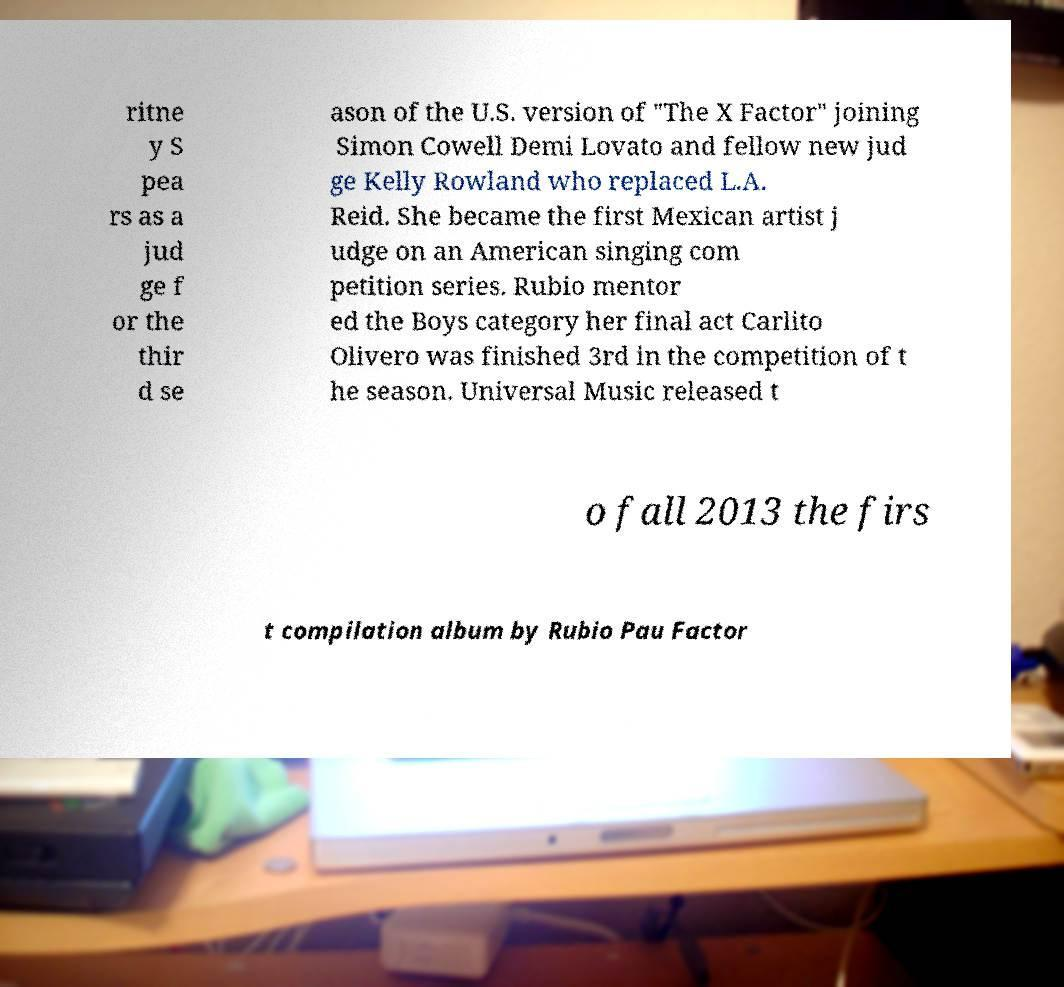I need the written content from this picture converted into text. Can you do that? ritne y S pea rs as a jud ge f or the thir d se ason of the U.S. version of "The X Factor" joining Simon Cowell Demi Lovato and fellow new jud ge Kelly Rowland who replaced L.A. Reid. She became the first Mexican artist j udge on an American singing com petition series. Rubio mentor ed the Boys category her final act Carlito Olivero was finished 3rd in the competition of t he season. Universal Music released t o fall 2013 the firs t compilation album by Rubio Pau Factor 